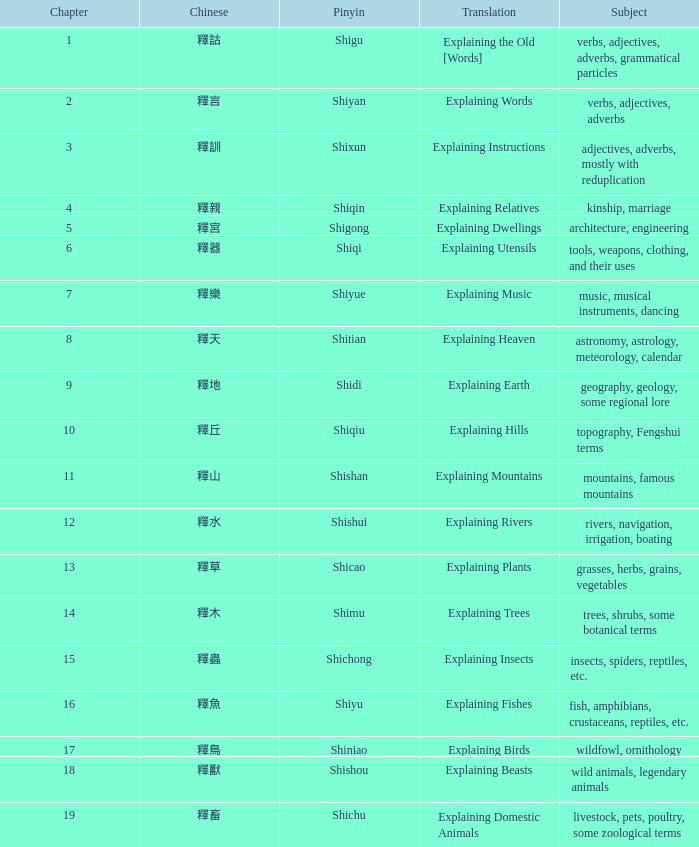Name the total number of chapter for chinese of 釋宮 1.0. 